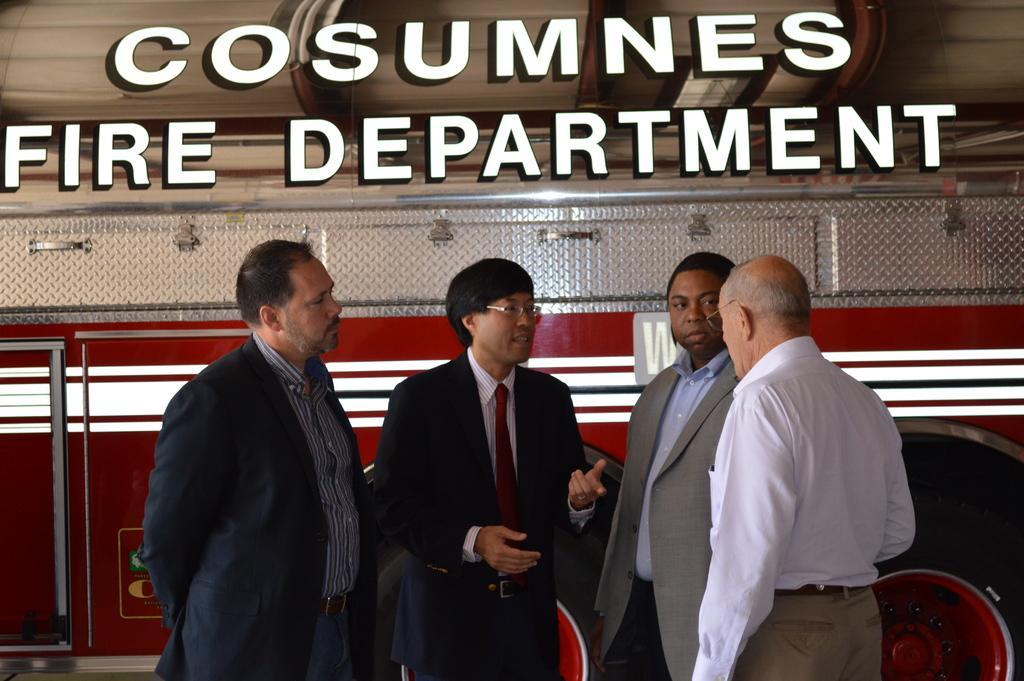Can you describe this image briefly? In this picture we can see a vehicle and group of men are standing, they are discussing. At the top portion of the picture there is something written. 